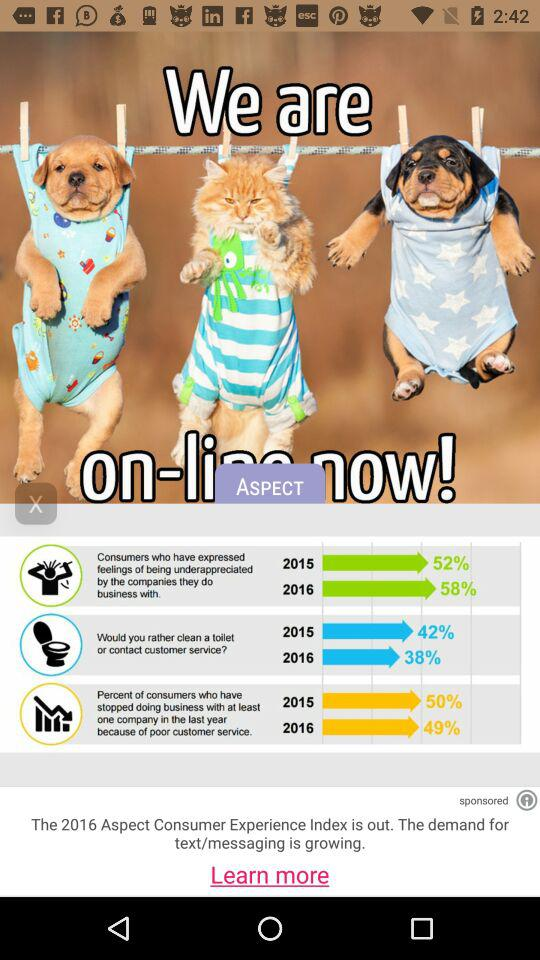How many more percent of consumers felt underappreciated by companies in 2016 vs 2015?
Answer the question using a single word or phrase. 6% 